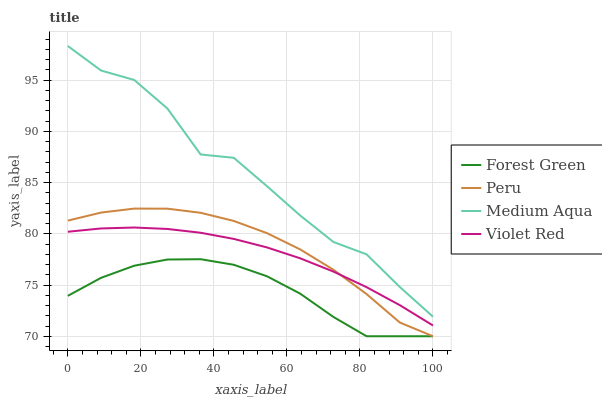Does Forest Green have the minimum area under the curve?
Answer yes or no. Yes. Does Medium Aqua have the maximum area under the curve?
Answer yes or no. Yes. Does Violet Red have the minimum area under the curve?
Answer yes or no. No. Does Violet Red have the maximum area under the curve?
Answer yes or no. No. Is Violet Red the smoothest?
Answer yes or no. Yes. Is Medium Aqua the roughest?
Answer yes or no. Yes. Is Medium Aqua the smoothest?
Answer yes or no. No. Is Violet Red the roughest?
Answer yes or no. No. Does Forest Green have the lowest value?
Answer yes or no. Yes. Does Violet Red have the lowest value?
Answer yes or no. No. Does Medium Aqua have the highest value?
Answer yes or no. Yes. Does Violet Red have the highest value?
Answer yes or no. No. Is Violet Red less than Medium Aqua?
Answer yes or no. Yes. Is Medium Aqua greater than Violet Red?
Answer yes or no. Yes. Does Forest Green intersect Peru?
Answer yes or no. Yes. Is Forest Green less than Peru?
Answer yes or no. No. Is Forest Green greater than Peru?
Answer yes or no. No. Does Violet Red intersect Medium Aqua?
Answer yes or no. No. 